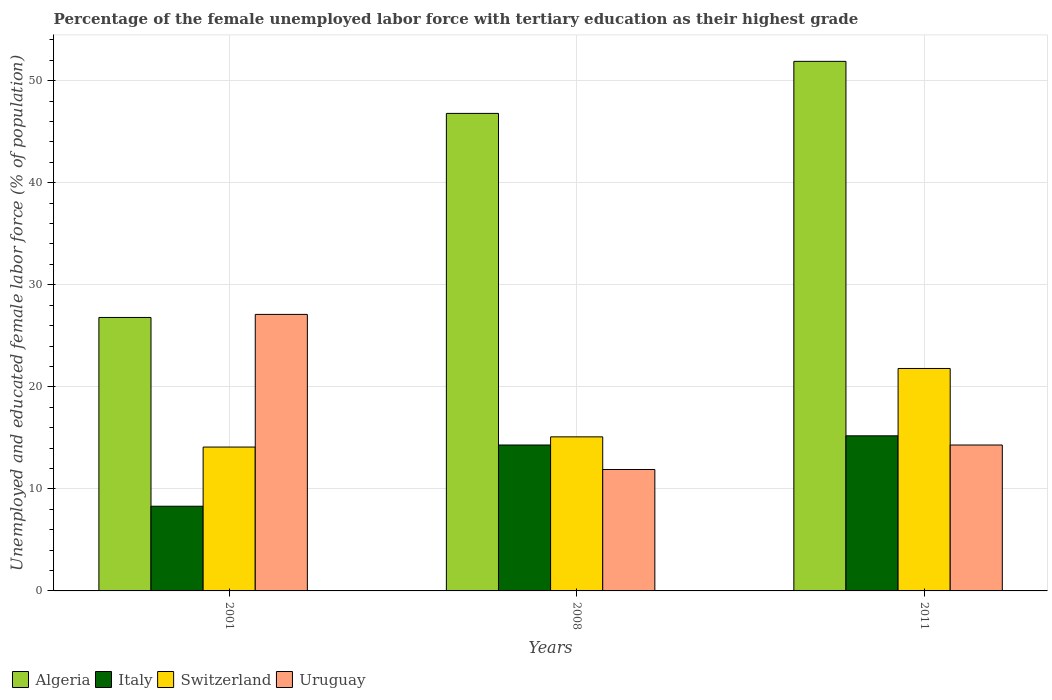Are the number of bars per tick equal to the number of legend labels?
Keep it short and to the point. Yes. Are the number of bars on each tick of the X-axis equal?
Ensure brevity in your answer.  Yes. How many bars are there on the 2nd tick from the right?
Your answer should be very brief. 4. What is the label of the 2nd group of bars from the left?
Your answer should be very brief. 2008. In how many cases, is the number of bars for a given year not equal to the number of legend labels?
Your response must be concise. 0. What is the percentage of the unemployed female labor force with tertiary education in Uruguay in 2008?
Provide a succinct answer. 11.9. Across all years, what is the maximum percentage of the unemployed female labor force with tertiary education in Uruguay?
Offer a very short reply. 27.1. Across all years, what is the minimum percentage of the unemployed female labor force with tertiary education in Switzerland?
Your response must be concise. 14.1. In which year was the percentage of the unemployed female labor force with tertiary education in Algeria minimum?
Make the answer very short. 2001. What is the total percentage of the unemployed female labor force with tertiary education in Algeria in the graph?
Make the answer very short. 125.5. What is the difference between the percentage of the unemployed female labor force with tertiary education in Italy in 2008 and that in 2011?
Keep it short and to the point. -0.9. What is the difference between the percentage of the unemployed female labor force with tertiary education in Algeria in 2008 and the percentage of the unemployed female labor force with tertiary education in Italy in 2001?
Your answer should be compact. 38.5. What is the average percentage of the unemployed female labor force with tertiary education in Italy per year?
Offer a very short reply. 12.6. In the year 2001, what is the difference between the percentage of the unemployed female labor force with tertiary education in Italy and percentage of the unemployed female labor force with tertiary education in Algeria?
Ensure brevity in your answer.  -18.5. What is the ratio of the percentage of the unemployed female labor force with tertiary education in Algeria in 2001 to that in 2011?
Provide a short and direct response. 0.52. Is the difference between the percentage of the unemployed female labor force with tertiary education in Italy in 2001 and 2008 greater than the difference between the percentage of the unemployed female labor force with tertiary education in Algeria in 2001 and 2008?
Your response must be concise. Yes. What is the difference between the highest and the second highest percentage of the unemployed female labor force with tertiary education in Italy?
Provide a short and direct response. 0.9. What is the difference between the highest and the lowest percentage of the unemployed female labor force with tertiary education in Switzerland?
Give a very brief answer. 7.7. What does the 4th bar from the left in 2008 represents?
Your answer should be compact. Uruguay. What does the 3rd bar from the right in 2001 represents?
Your answer should be compact. Italy. Is it the case that in every year, the sum of the percentage of the unemployed female labor force with tertiary education in Uruguay and percentage of the unemployed female labor force with tertiary education in Switzerland is greater than the percentage of the unemployed female labor force with tertiary education in Italy?
Offer a very short reply. Yes. Are all the bars in the graph horizontal?
Offer a terse response. No. What is the difference between two consecutive major ticks on the Y-axis?
Provide a succinct answer. 10. Does the graph contain grids?
Provide a succinct answer. Yes. Where does the legend appear in the graph?
Keep it short and to the point. Bottom left. How are the legend labels stacked?
Ensure brevity in your answer.  Horizontal. What is the title of the graph?
Your answer should be very brief. Percentage of the female unemployed labor force with tertiary education as their highest grade. What is the label or title of the Y-axis?
Your response must be concise. Unemployed and educated female labor force (% of population). What is the Unemployed and educated female labor force (% of population) in Algeria in 2001?
Provide a short and direct response. 26.8. What is the Unemployed and educated female labor force (% of population) of Italy in 2001?
Your response must be concise. 8.3. What is the Unemployed and educated female labor force (% of population) in Switzerland in 2001?
Make the answer very short. 14.1. What is the Unemployed and educated female labor force (% of population) in Uruguay in 2001?
Provide a succinct answer. 27.1. What is the Unemployed and educated female labor force (% of population) in Algeria in 2008?
Keep it short and to the point. 46.8. What is the Unemployed and educated female labor force (% of population) in Italy in 2008?
Your response must be concise. 14.3. What is the Unemployed and educated female labor force (% of population) in Switzerland in 2008?
Your response must be concise. 15.1. What is the Unemployed and educated female labor force (% of population) of Uruguay in 2008?
Offer a very short reply. 11.9. What is the Unemployed and educated female labor force (% of population) of Algeria in 2011?
Your answer should be compact. 51.9. What is the Unemployed and educated female labor force (% of population) of Italy in 2011?
Your answer should be compact. 15.2. What is the Unemployed and educated female labor force (% of population) in Switzerland in 2011?
Your answer should be compact. 21.8. What is the Unemployed and educated female labor force (% of population) of Uruguay in 2011?
Your response must be concise. 14.3. Across all years, what is the maximum Unemployed and educated female labor force (% of population) in Algeria?
Ensure brevity in your answer.  51.9. Across all years, what is the maximum Unemployed and educated female labor force (% of population) of Italy?
Make the answer very short. 15.2. Across all years, what is the maximum Unemployed and educated female labor force (% of population) in Switzerland?
Make the answer very short. 21.8. Across all years, what is the maximum Unemployed and educated female labor force (% of population) of Uruguay?
Provide a succinct answer. 27.1. Across all years, what is the minimum Unemployed and educated female labor force (% of population) of Algeria?
Offer a very short reply. 26.8. Across all years, what is the minimum Unemployed and educated female labor force (% of population) in Italy?
Ensure brevity in your answer.  8.3. Across all years, what is the minimum Unemployed and educated female labor force (% of population) of Switzerland?
Give a very brief answer. 14.1. Across all years, what is the minimum Unemployed and educated female labor force (% of population) of Uruguay?
Your response must be concise. 11.9. What is the total Unemployed and educated female labor force (% of population) in Algeria in the graph?
Give a very brief answer. 125.5. What is the total Unemployed and educated female labor force (% of population) of Italy in the graph?
Make the answer very short. 37.8. What is the total Unemployed and educated female labor force (% of population) of Uruguay in the graph?
Your answer should be compact. 53.3. What is the difference between the Unemployed and educated female labor force (% of population) in Algeria in 2001 and that in 2011?
Make the answer very short. -25.1. What is the difference between the Unemployed and educated female labor force (% of population) in Italy in 2001 and that in 2011?
Keep it short and to the point. -6.9. What is the difference between the Unemployed and educated female labor force (% of population) of Uruguay in 2001 and that in 2011?
Keep it short and to the point. 12.8. What is the difference between the Unemployed and educated female labor force (% of population) of Uruguay in 2008 and that in 2011?
Ensure brevity in your answer.  -2.4. What is the difference between the Unemployed and educated female labor force (% of population) in Algeria in 2001 and the Unemployed and educated female labor force (% of population) in Uruguay in 2008?
Your response must be concise. 14.9. What is the difference between the Unemployed and educated female labor force (% of population) in Italy in 2001 and the Unemployed and educated female labor force (% of population) in Switzerland in 2008?
Offer a very short reply. -6.8. What is the difference between the Unemployed and educated female labor force (% of population) in Switzerland in 2001 and the Unemployed and educated female labor force (% of population) in Uruguay in 2008?
Make the answer very short. 2.2. What is the difference between the Unemployed and educated female labor force (% of population) in Italy in 2001 and the Unemployed and educated female labor force (% of population) in Uruguay in 2011?
Give a very brief answer. -6. What is the difference between the Unemployed and educated female labor force (% of population) in Algeria in 2008 and the Unemployed and educated female labor force (% of population) in Italy in 2011?
Provide a succinct answer. 31.6. What is the difference between the Unemployed and educated female labor force (% of population) of Algeria in 2008 and the Unemployed and educated female labor force (% of population) of Switzerland in 2011?
Your answer should be very brief. 25. What is the difference between the Unemployed and educated female labor force (% of population) in Algeria in 2008 and the Unemployed and educated female labor force (% of population) in Uruguay in 2011?
Keep it short and to the point. 32.5. What is the difference between the Unemployed and educated female labor force (% of population) in Italy in 2008 and the Unemployed and educated female labor force (% of population) in Switzerland in 2011?
Ensure brevity in your answer.  -7.5. What is the difference between the Unemployed and educated female labor force (% of population) of Italy in 2008 and the Unemployed and educated female labor force (% of population) of Uruguay in 2011?
Give a very brief answer. 0. What is the average Unemployed and educated female labor force (% of population) in Algeria per year?
Your answer should be compact. 41.83. What is the average Unemployed and educated female labor force (% of population) in Switzerland per year?
Your answer should be compact. 17. What is the average Unemployed and educated female labor force (% of population) in Uruguay per year?
Give a very brief answer. 17.77. In the year 2001, what is the difference between the Unemployed and educated female labor force (% of population) of Algeria and Unemployed and educated female labor force (% of population) of Italy?
Provide a succinct answer. 18.5. In the year 2001, what is the difference between the Unemployed and educated female labor force (% of population) in Italy and Unemployed and educated female labor force (% of population) in Uruguay?
Provide a succinct answer. -18.8. In the year 2008, what is the difference between the Unemployed and educated female labor force (% of population) in Algeria and Unemployed and educated female labor force (% of population) in Italy?
Your answer should be very brief. 32.5. In the year 2008, what is the difference between the Unemployed and educated female labor force (% of population) of Algeria and Unemployed and educated female labor force (% of population) of Switzerland?
Your answer should be very brief. 31.7. In the year 2008, what is the difference between the Unemployed and educated female labor force (% of population) in Algeria and Unemployed and educated female labor force (% of population) in Uruguay?
Your response must be concise. 34.9. In the year 2008, what is the difference between the Unemployed and educated female labor force (% of population) of Italy and Unemployed and educated female labor force (% of population) of Switzerland?
Make the answer very short. -0.8. In the year 2011, what is the difference between the Unemployed and educated female labor force (% of population) of Algeria and Unemployed and educated female labor force (% of population) of Italy?
Make the answer very short. 36.7. In the year 2011, what is the difference between the Unemployed and educated female labor force (% of population) of Algeria and Unemployed and educated female labor force (% of population) of Switzerland?
Provide a short and direct response. 30.1. In the year 2011, what is the difference between the Unemployed and educated female labor force (% of population) in Algeria and Unemployed and educated female labor force (% of population) in Uruguay?
Ensure brevity in your answer.  37.6. In the year 2011, what is the difference between the Unemployed and educated female labor force (% of population) of Italy and Unemployed and educated female labor force (% of population) of Uruguay?
Your answer should be compact. 0.9. In the year 2011, what is the difference between the Unemployed and educated female labor force (% of population) of Switzerland and Unemployed and educated female labor force (% of population) of Uruguay?
Your response must be concise. 7.5. What is the ratio of the Unemployed and educated female labor force (% of population) of Algeria in 2001 to that in 2008?
Provide a succinct answer. 0.57. What is the ratio of the Unemployed and educated female labor force (% of population) in Italy in 2001 to that in 2008?
Give a very brief answer. 0.58. What is the ratio of the Unemployed and educated female labor force (% of population) of Switzerland in 2001 to that in 2008?
Ensure brevity in your answer.  0.93. What is the ratio of the Unemployed and educated female labor force (% of population) of Uruguay in 2001 to that in 2008?
Your answer should be very brief. 2.28. What is the ratio of the Unemployed and educated female labor force (% of population) of Algeria in 2001 to that in 2011?
Give a very brief answer. 0.52. What is the ratio of the Unemployed and educated female labor force (% of population) in Italy in 2001 to that in 2011?
Provide a succinct answer. 0.55. What is the ratio of the Unemployed and educated female labor force (% of population) of Switzerland in 2001 to that in 2011?
Give a very brief answer. 0.65. What is the ratio of the Unemployed and educated female labor force (% of population) in Uruguay in 2001 to that in 2011?
Your answer should be very brief. 1.9. What is the ratio of the Unemployed and educated female labor force (% of population) of Algeria in 2008 to that in 2011?
Your answer should be very brief. 0.9. What is the ratio of the Unemployed and educated female labor force (% of population) of Italy in 2008 to that in 2011?
Provide a succinct answer. 0.94. What is the ratio of the Unemployed and educated female labor force (% of population) in Switzerland in 2008 to that in 2011?
Give a very brief answer. 0.69. What is the ratio of the Unemployed and educated female labor force (% of population) in Uruguay in 2008 to that in 2011?
Give a very brief answer. 0.83. What is the difference between the highest and the second highest Unemployed and educated female labor force (% of population) in Algeria?
Provide a succinct answer. 5.1. What is the difference between the highest and the second highest Unemployed and educated female labor force (% of population) in Uruguay?
Provide a succinct answer. 12.8. What is the difference between the highest and the lowest Unemployed and educated female labor force (% of population) of Algeria?
Provide a short and direct response. 25.1. What is the difference between the highest and the lowest Unemployed and educated female labor force (% of population) in Italy?
Provide a short and direct response. 6.9. What is the difference between the highest and the lowest Unemployed and educated female labor force (% of population) in Switzerland?
Offer a terse response. 7.7. What is the difference between the highest and the lowest Unemployed and educated female labor force (% of population) in Uruguay?
Ensure brevity in your answer.  15.2. 